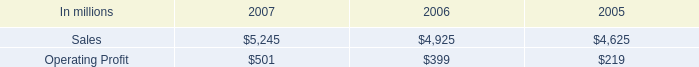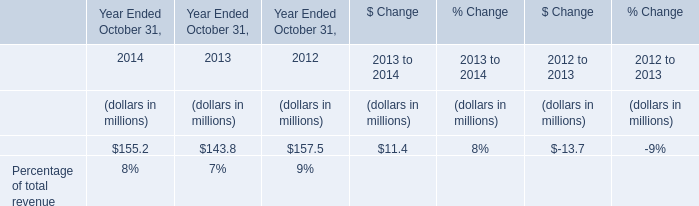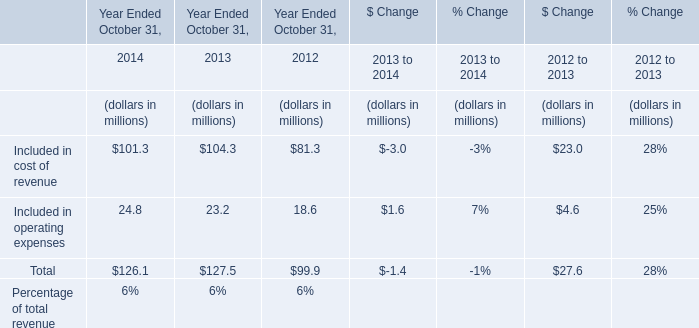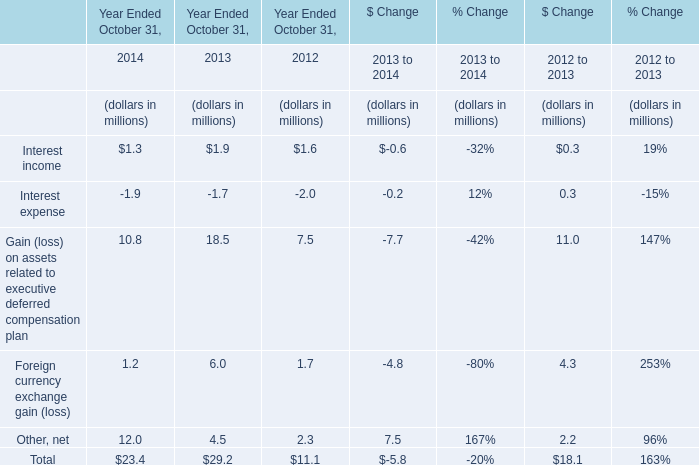What is the sum of the Interest expense in the years where Interest income is greater than 1 for Year Ended October 31, (in million) 
Computations: ((-1.9 - 1.7) - 2.0)
Answer: -5.6. 